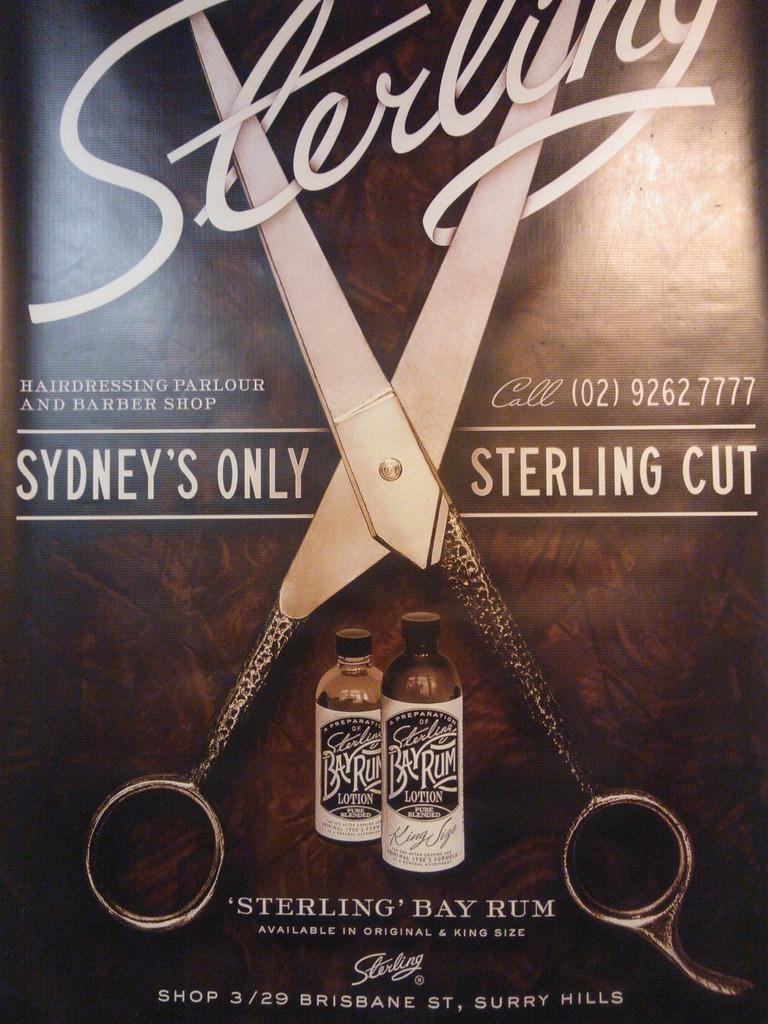<image>
Share a concise interpretation of the image provided. A pair of scissors are visible in a Sterling Rum ad. 